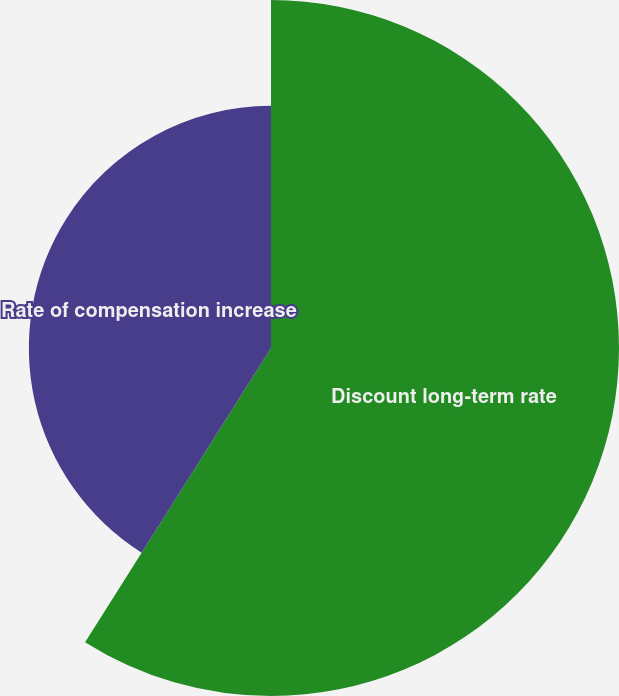Convert chart. <chart><loc_0><loc_0><loc_500><loc_500><pie_chart><fcel>Discount long-term rate<fcel>Rate of compensation increase<nl><fcel>58.97%<fcel>41.03%<nl></chart> 